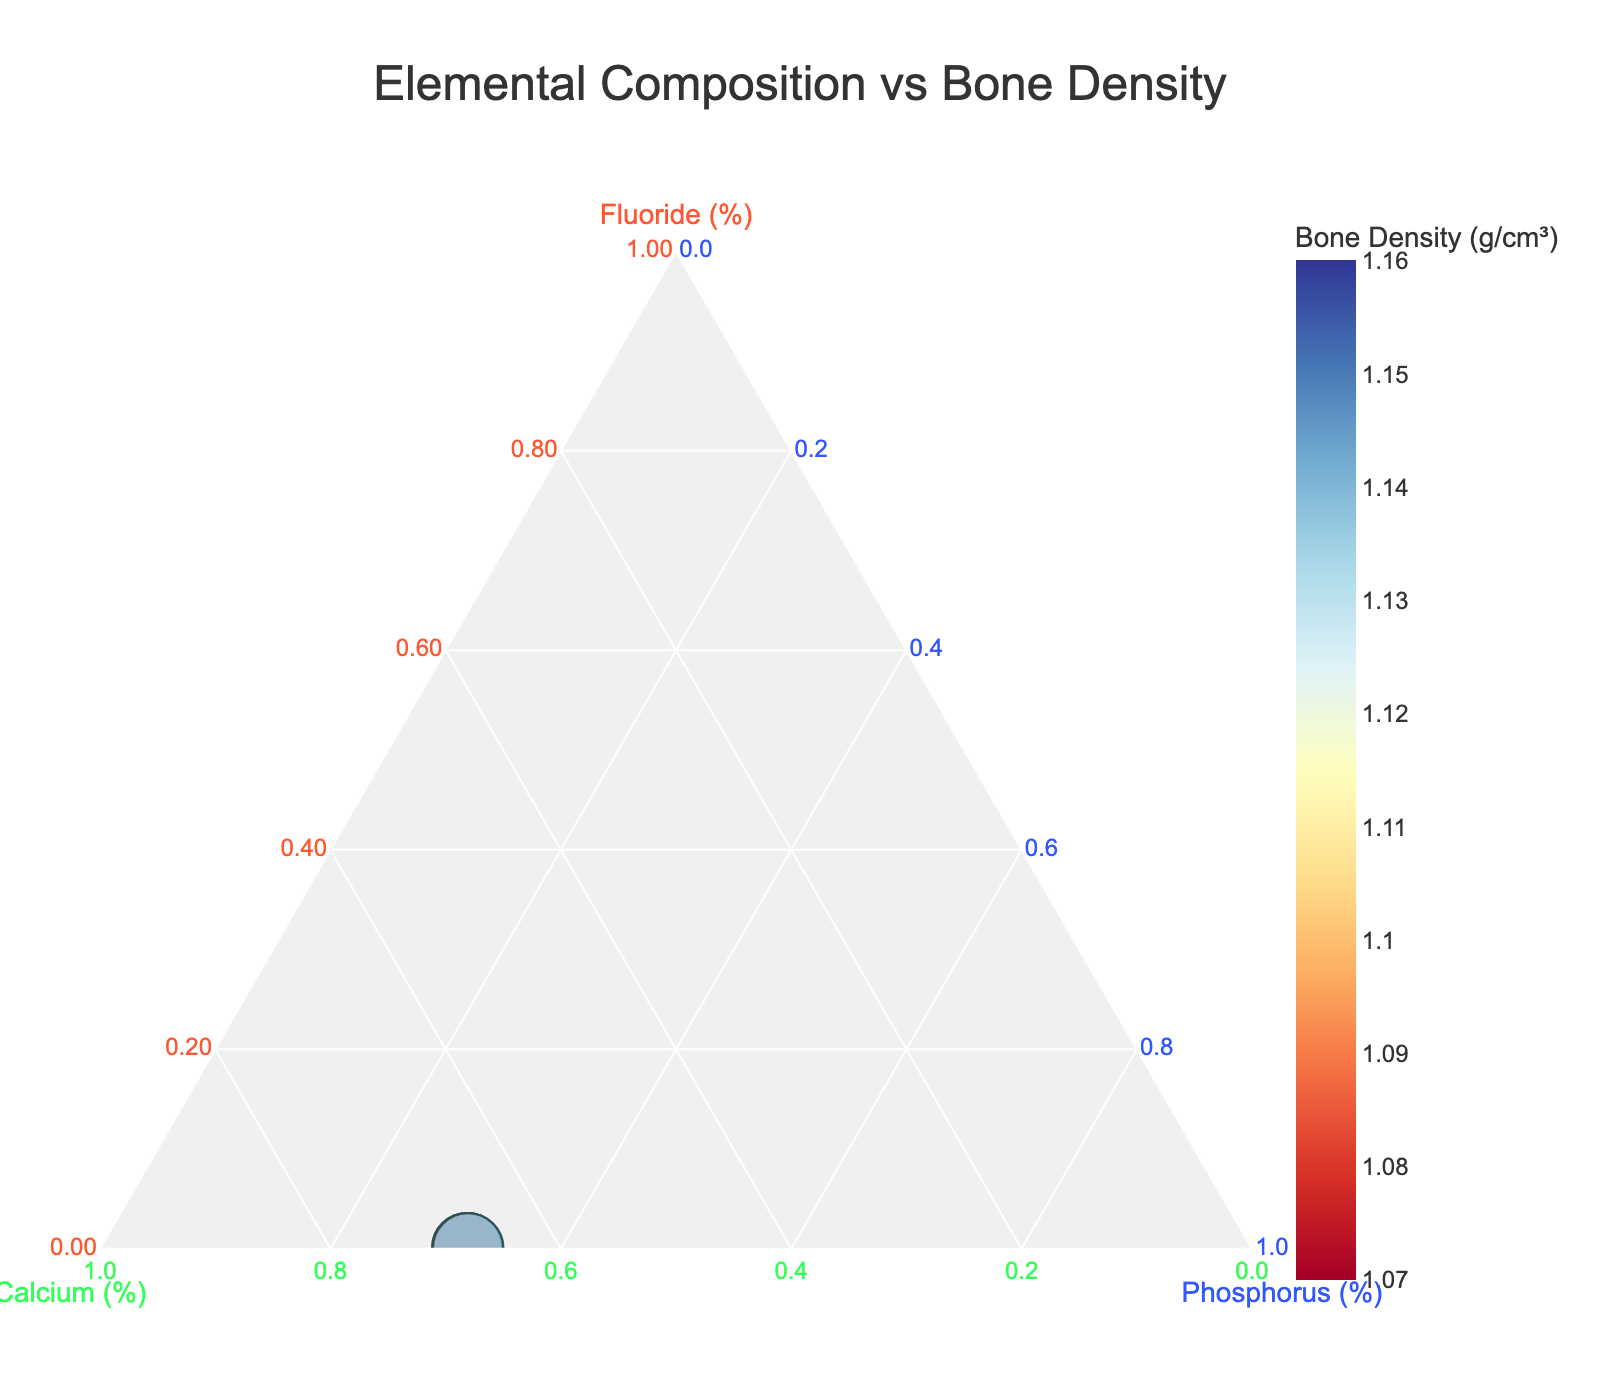Which element has the highest proportion in the bone samples? By looking at the positions of data points in the ternary plot, we can see that the points are generally close to the Calcium axis, indicating that calcium is the most dominant element in the bone samples.
Answer: Calcium What is the title of the ternary plot? The title is located at the top center of the plot.
Answer: Elemental Composition vs Bone Density Which specimen has the highest bone density? By examining the size and color of the markers, the Rib_05 specimen stands out with the largest size and the darkest color, indicating the highest bone density.
Answer: Rib_05 What is the range of bone density in the samples? The color bar on the right side shows the bone density range. It starts approximately from 1.07 and goes up to around 1.16 g/cm³.
Answer: 1.07 to 1.16 g/cm³ Which specimens have the lowest fluoride content? Points near the corner labeled "Fluoride" correspond to specimens with low fluoride content. Both Vertebra_L2 and Rib_05 are positioned close to this corner.
Answer: Vertebra_L2, Rib_05 How does the fluoride content of Skull_02 compare to that of Pelvis_04? Skull_02 is positioned farther up the "Fluoride" axis compared to Pelvis_04, indicating that Skull_02 has a higher fluoride content.
Answer: Higher Is there a correlation between high bone density and high calcium content? Data points with high bone density (larger and darker) are closely clustered along the side of the ternary plot that represents high calcium content, suggesting a positive correlation.
Answer: Yes What specimen has nearly equal proportions of calcium and phosphorus? Points near the line dividing the Calcium and Phosphorus axes indicate nearly equal proportions. Clavicle_01 seems to match this criterion.
Answer: Clavicle_01 What is the phosphorus proportion in the Vertebra_L2 specimen? The point representing Vertebra_L2 lies close to the bottom side of the ternary plot, indicating a higher value on the Phosphorus axis. By estimation, the proportion is approximately 29-30%.
Answer: 29-30% What specimen lies closest to the centroid of the ternary plot and why might this be significant? The centroid represents balanced proportions of all three elements. Ulna_03 is closest, indicating it has a more uniform elemental composition compared to others.
Answer: Ulna_03 